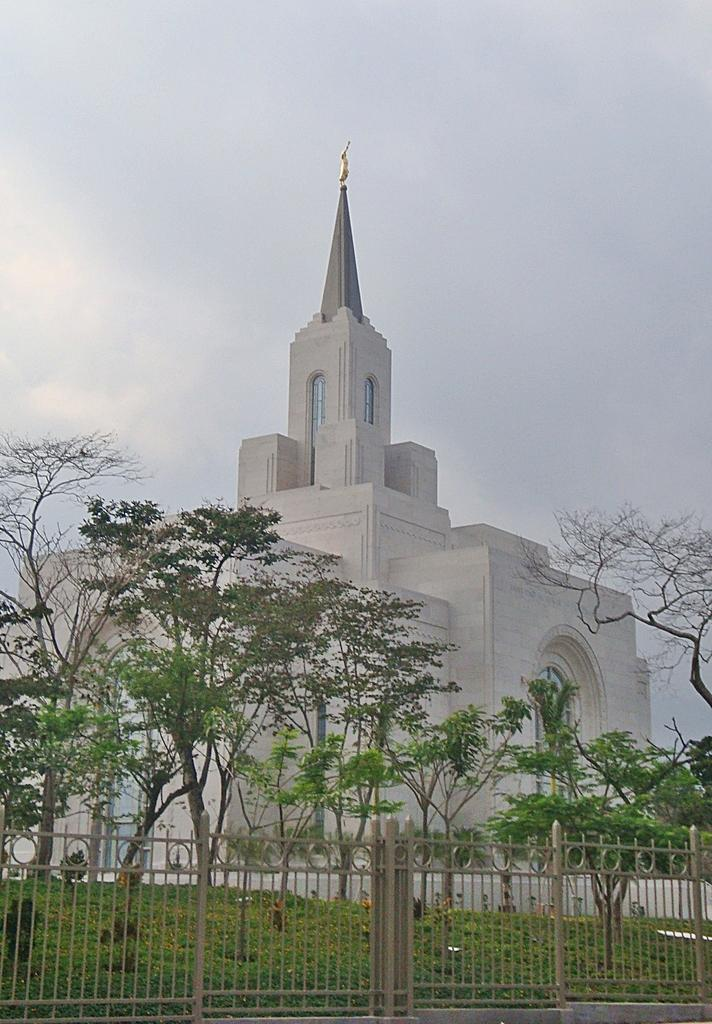What type of structures can be seen in the image? There are buildings in the image. What type of vegetation is present in the image? There are trees in the image. What type of entrance is visible in the image? There is a gate in the image. What is the surface visible in the image? The ground is visible in the image. What type of ground cover can be seen in the image? The ground is covered with grass in the image. What type of alarm is ringing in the image? There is no alarm present in the image. How many cents are visible in the image? There are no cents present in the image. 